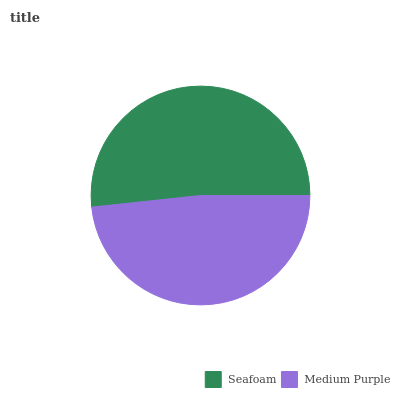Is Medium Purple the minimum?
Answer yes or no. Yes. Is Seafoam the maximum?
Answer yes or no. Yes. Is Medium Purple the maximum?
Answer yes or no. No. Is Seafoam greater than Medium Purple?
Answer yes or no. Yes. Is Medium Purple less than Seafoam?
Answer yes or no. Yes. Is Medium Purple greater than Seafoam?
Answer yes or no. No. Is Seafoam less than Medium Purple?
Answer yes or no. No. Is Seafoam the high median?
Answer yes or no. Yes. Is Medium Purple the low median?
Answer yes or no. Yes. Is Medium Purple the high median?
Answer yes or no. No. Is Seafoam the low median?
Answer yes or no. No. 